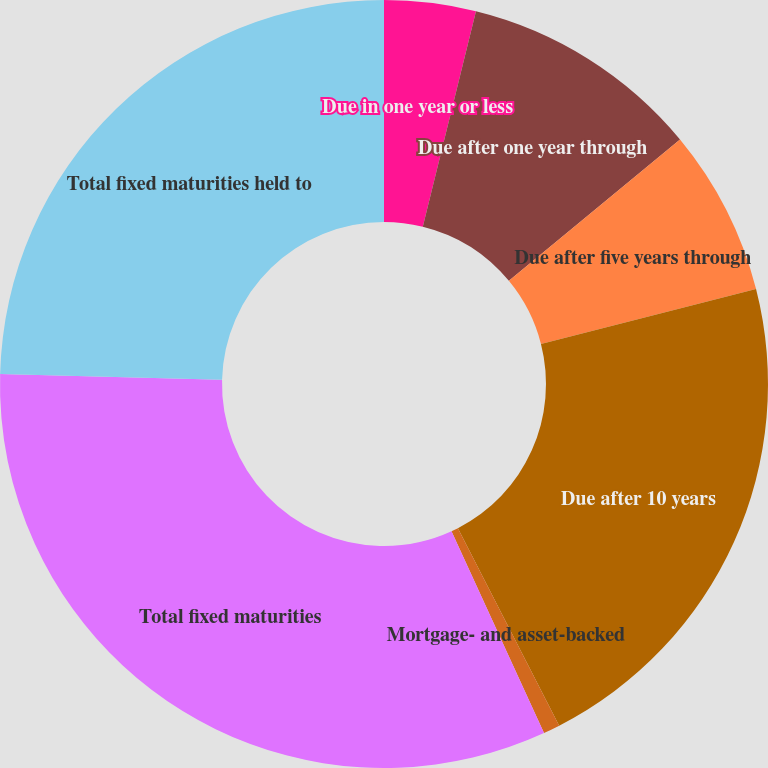Convert chart. <chart><loc_0><loc_0><loc_500><loc_500><pie_chart><fcel>Due in one year or less<fcel>Due after one year through<fcel>Due after five years through<fcel>Due after 10 years<fcel>Mortgage- and asset-backed<fcel>Total fixed maturities<fcel>Total fixed maturities held to<nl><fcel>3.85%<fcel>10.16%<fcel>7.01%<fcel>21.44%<fcel>0.7%<fcel>32.25%<fcel>24.59%<nl></chart> 